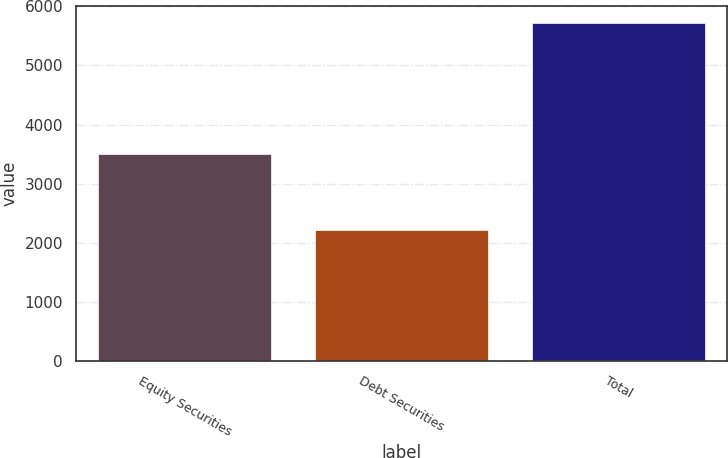<chart> <loc_0><loc_0><loc_500><loc_500><bar_chart><fcel>Equity Securities<fcel>Debt Securities<fcel>Total<nl><fcel>3511<fcel>2213<fcel>5724<nl></chart> 